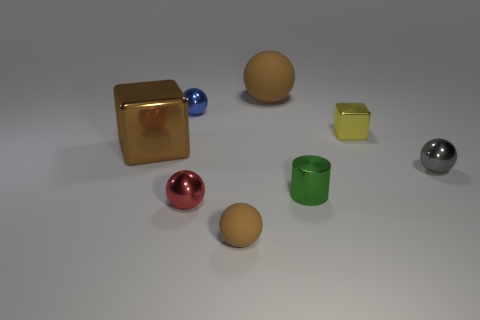Subtract all red spheres. How many spheres are left? 4 Subtract all large balls. How many balls are left? 4 Subtract 1 balls. How many balls are left? 4 Subtract all purple balls. Subtract all yellow cylinders. How many balls are left? 5 Add 1 tiny blocks. How many objects exist? 9 Subtract all cylinders. How many objects are left? 7 Add 1 red metal things. How many red metal things exist? 2 Subtract 0 yellow balls. How many objects are left? 8 Subtract all red objects. Subtract all big brown things. How many objects are left? 5 Add 3 brown rubber balls. How many brown rubber balls are left? 5 